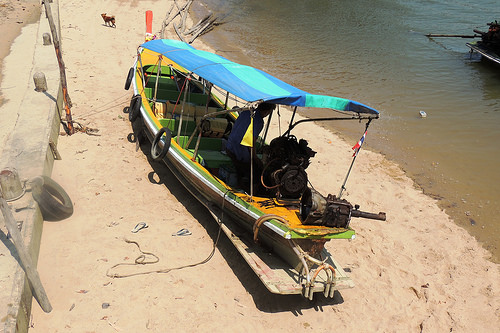<image>
Is the boat next to the river? Yes. The boat is positioned adjacent to the river, located nearby in the same general area. Is there a boat in the water? No. The boat is not contained within the water. These objects have a different spatial relationship. 